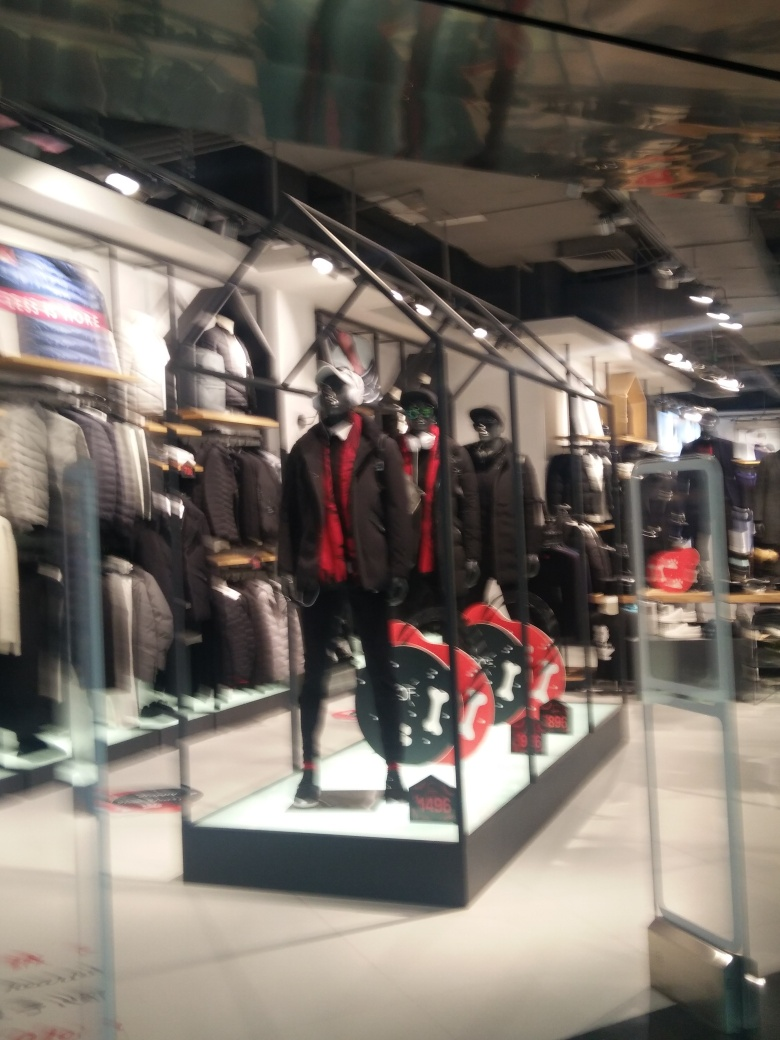What style and era of fashion do the mannequins in this image represent? The mannequins exhibit a modern, trendy styling with dark, tailored suits accented by bold details like red ties, which adds a contemporary vibrance typical of 21st-century design elements in urban fashion. 